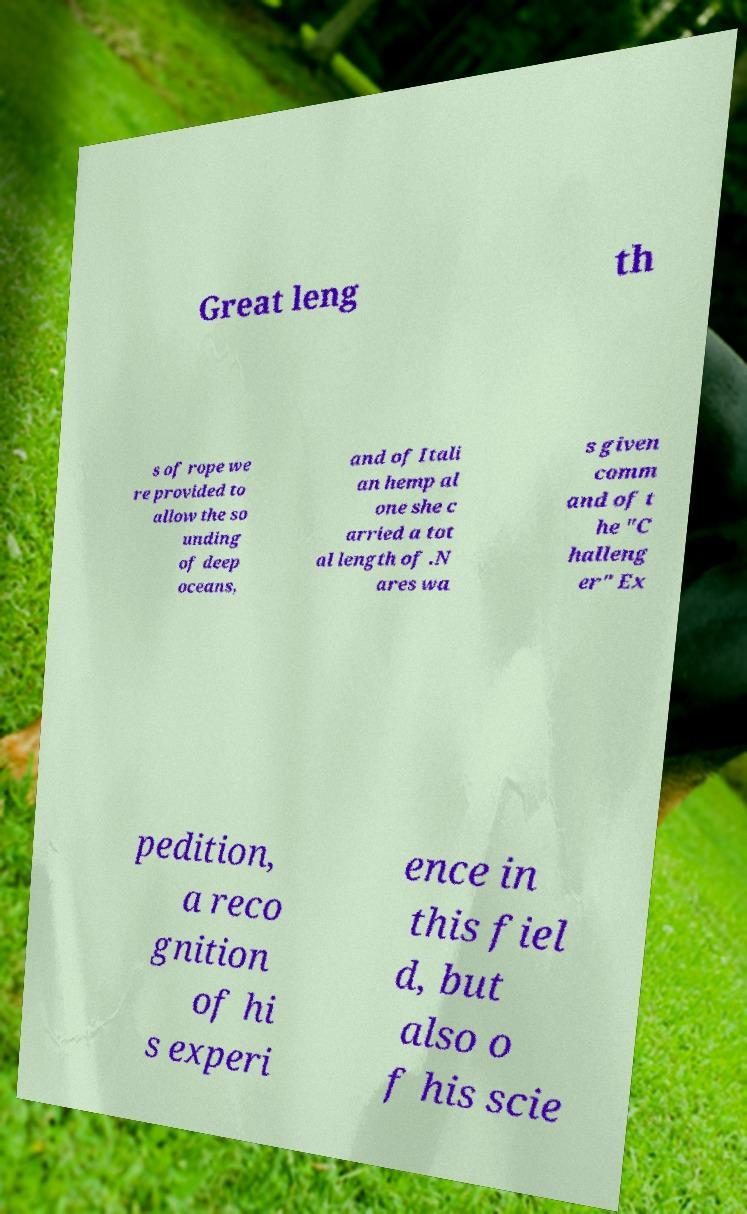Please read and relay the text visible in this image. What does it say? Great leng th s of rope we re provided to allow the so unding of deep oceans, and of Itali an hemp al one she c arried a tot al length of .N ares wa s given comm and of t he "C halleng er" Ex pedition, a reco gnition of hi s experi ence in this fiel d, but also o f his scie 